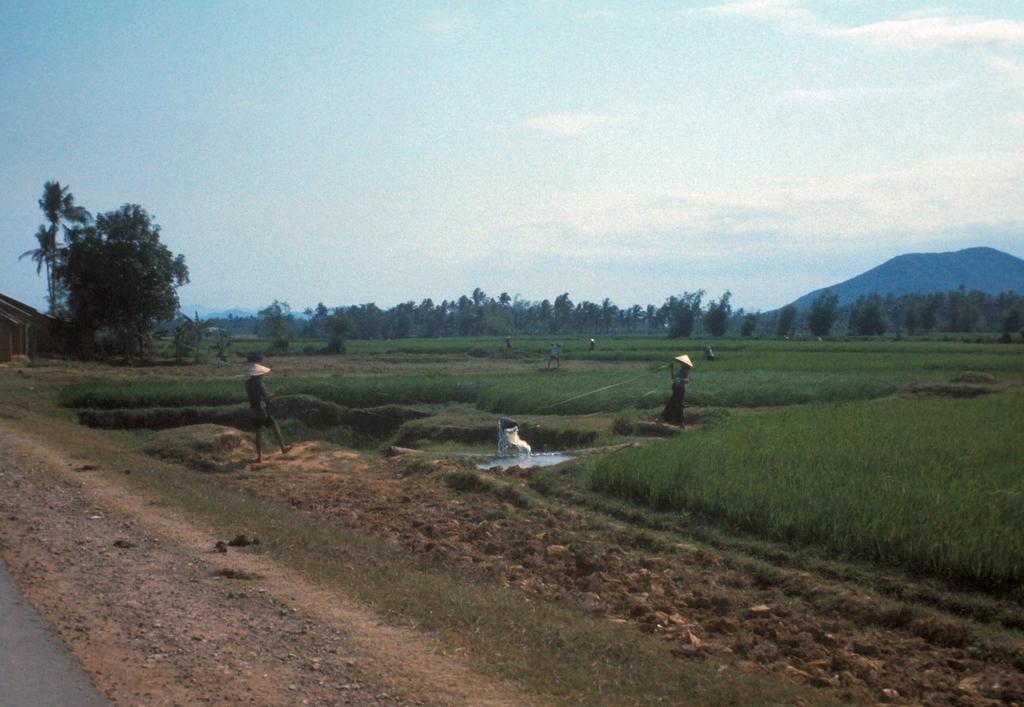Describe this image in one or two sentences. In this image there is a grass on the surface and there are few people walking on the path. On the left side of the image there is a shed. In the background there are trees, mountains and the sky. 